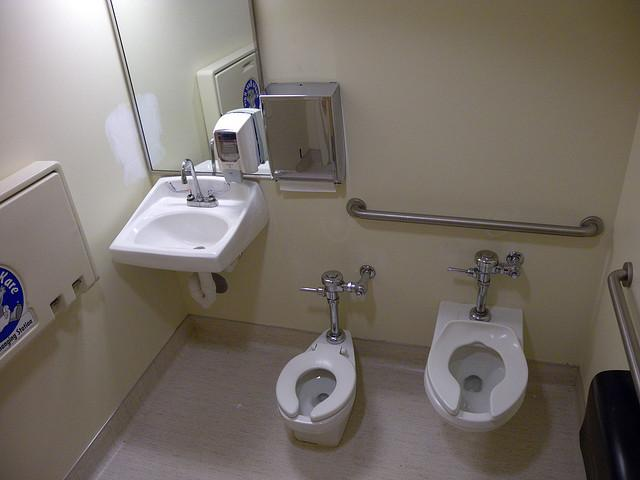How many items appear to be made of porcelain?

Choices:
A) six
B) eight
C) three
D) five three 